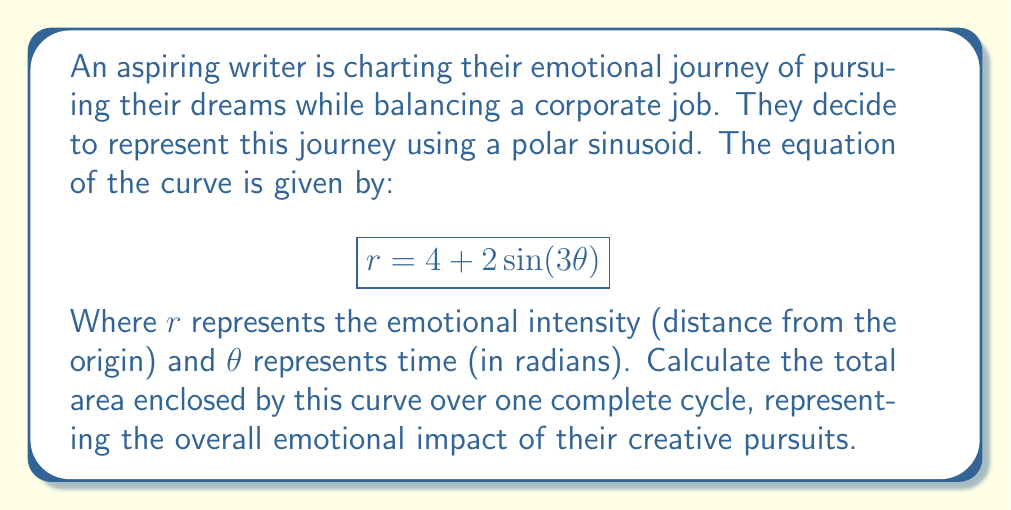Could you help me with this problem? To solve this problem, we'll follow these steps:

1) First, we need to determine the period of the curve. The period is given by $\frac{2\pi}{n}$, where $n$ is the coefficient of $\theta$ in the sine function. Here, $n=3$, so the period is $\frac{2\pi}{3}$.

2) The area of a polar curve over an interval $[a,b]$ is given by the formula:

   $$A = \frac{1}{2} \int_a^b r^2(\theta) d\theta$$

3) We need to substitute our equation $r = 4 + 2\sin(3\theta)$ into this formula:

   $$A = \frac{1}{2} \int_0^{2\pi/3} (4 + 2\sin(3\theta))^2 d\theta$$

4) Expand the squared term:

   $$A = \frac{1}{2} \int_0^{2\pi/3} (16 + 16\sin(3\theta) + 4\sin^2(3\theta)) d\theta$$

5) Use the identity $\sin^2(x) = \frac{1 - \cos(2x)}{2}$:

   $$A = \frac{1}{2} \int_0^{2\pi/3} (16 + 16\sin(3\theta) + 2 - 2\cos(6\theta)) d\theta$$
   $$A = \frac{1}{2} \int_0^{2\pi/3} (18 + 16\sin(3\theta) - 2\cos(6\theta)) d\theta$$

6) Integrate term by term:

   $$A = \frac{1}{2} [18\theta - \frac{16}{3}\cos(3\theta) + \frac{1}{3}\sin(6\theta)]_0^{2\pi/3}$$

7) Evaluate the definite integral:

   $$A = \frac{1}{2} [(18 \cdot \frac{2\pi}{3} - \frac{16}{3}\cos(2\pi) + \frac{1}{3}\sin(4\pi)) - (0 - \frac{16}{3} + 0)]$$
   $$A = \frac{1}{2} [12\pi - \frac{16}{3} + \frac{16}{3}] = 6\pi$$

Therefore, the total area enclosed by the curve is $6\pi$ square units.
Answer: $6\pi$ square units 